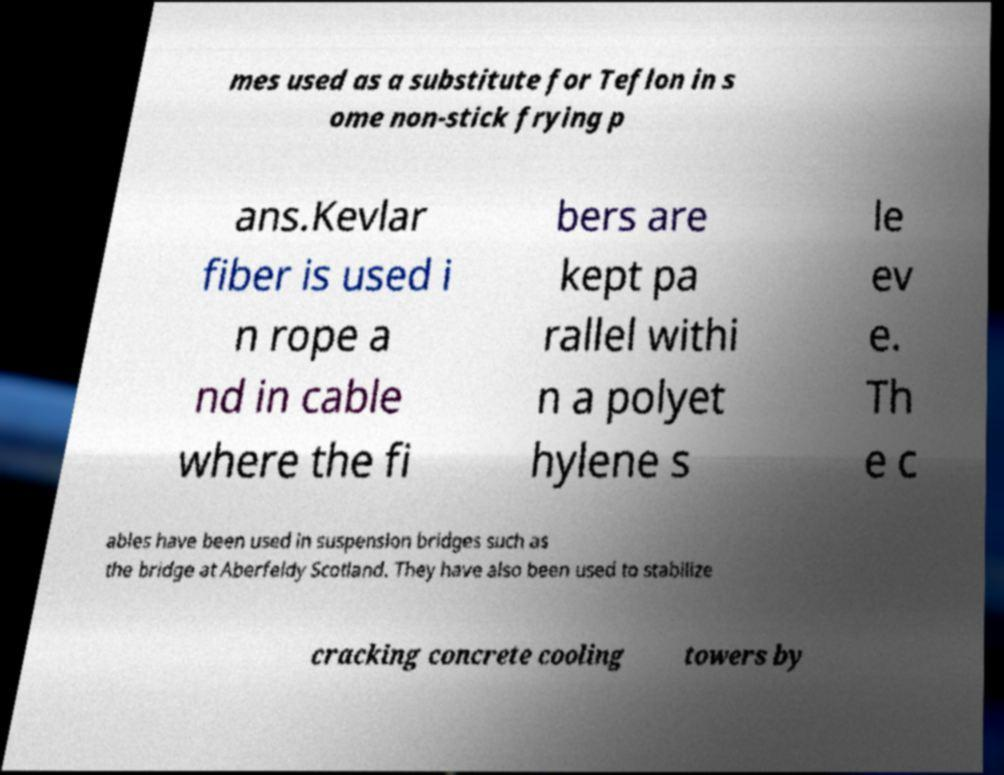Can you accurately transcribe the text from the provided image for me? mes used as a substitute for Teflon in s ome non-stick frying p ans.Kevlar fiber is used i n rope a nd in cable where the fi bers are kept pa rallel withi n a polyet hylene s le ev e. Th e c ables have been used in suspension bridges such as the bridge at Aberfeldy Scotland. They have also been used to stabilize cracking concrete cooling towers by 